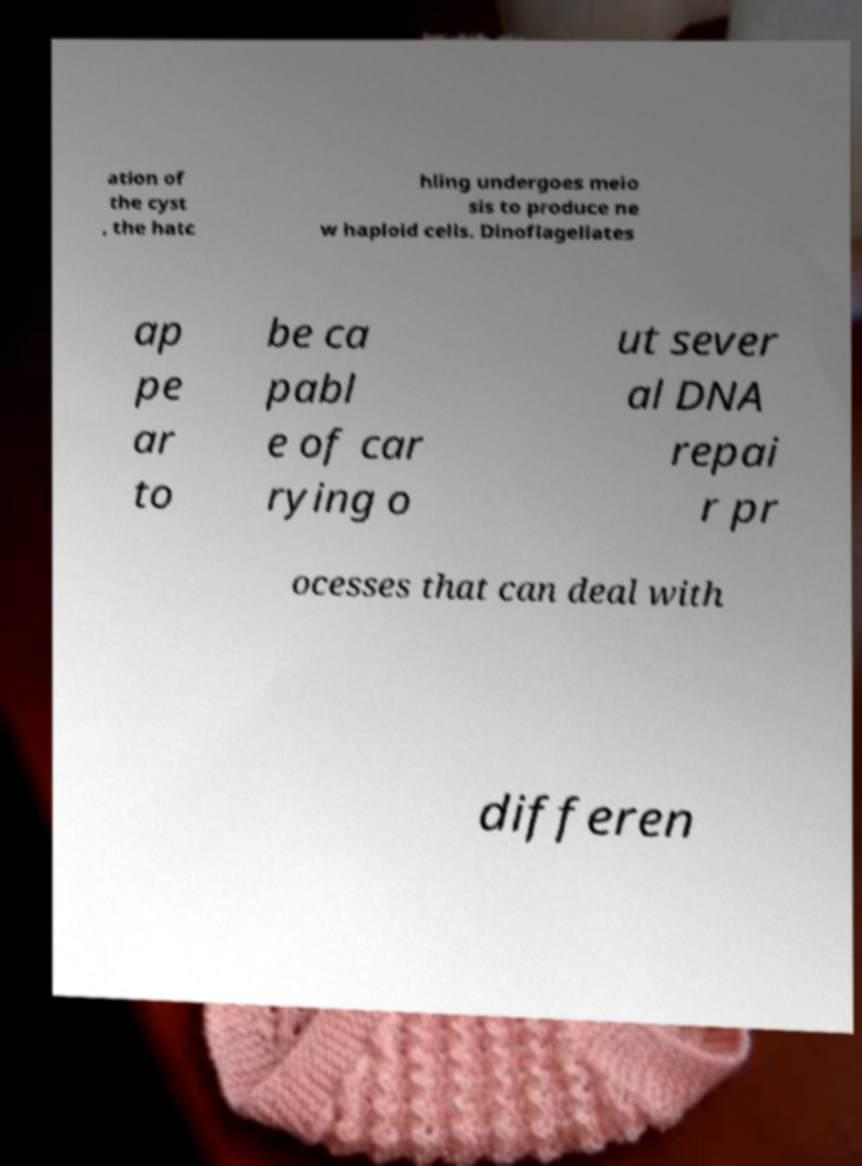Could you assist in decoding the text presented in this image and type it out clearly? ation of the cyst , the hatc hling undergoes meio sis to produce ne w haploid cells. Dinoflagellates ap pe ar to be ca pabl e of car rying o ut sever al DNA repai r pr ocesses that can deal with differen 